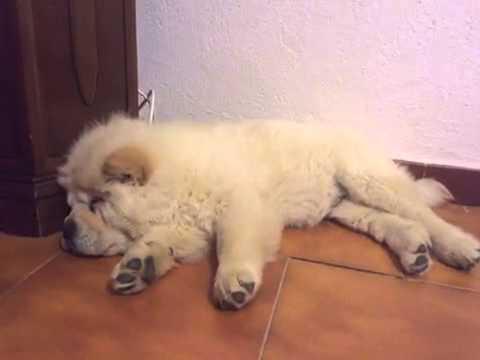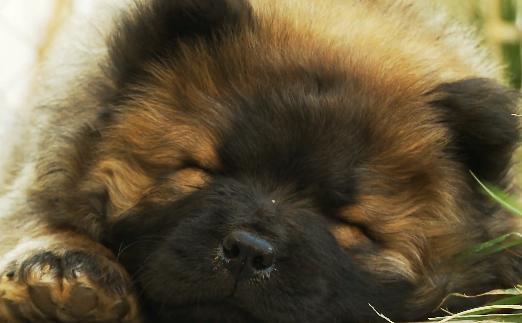The first image is the image on the left, the second image is the image on the right. For the images displayed, is the sentence "In one image in each pair a dog is sleeping on a linoleum floor." factually correct? Answer yes or no. Yes. The first image is the image on the left, the second image is the image on the right. For the images displayed, is the sentence "There is a toy visible in one of the images." factually correct? Answer yes or no. No. 